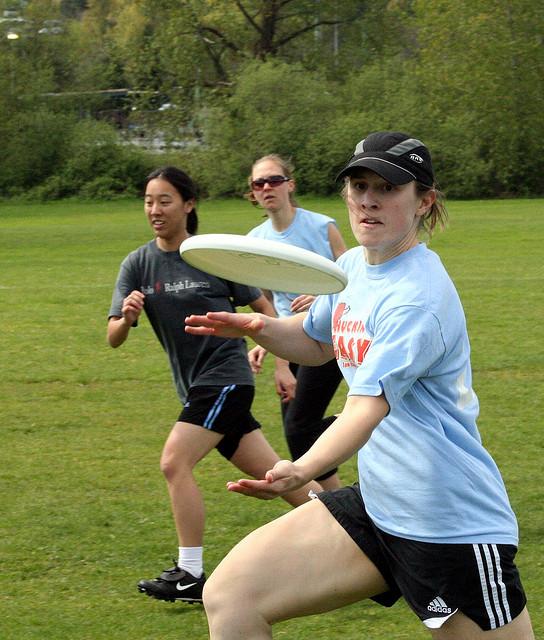How many of the women have stripes on their pants?
Concise answer only. 2. How many women are there?
Write a very short answer. 3. What sport is being played?
Answer briefly. Frisbee. What is flying in the air?
Quick response, please. Frisbee. Are the players wearing shin guards?
Answer briefly. No. What color is the frisbee?
Concise answer only. White. 